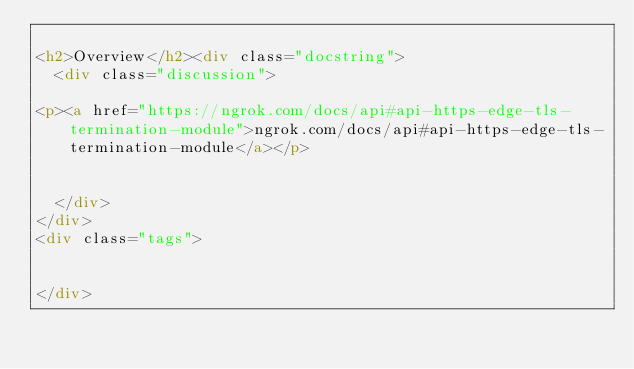<code> <loc_0><loc_0><loc_500><loc_500><_HTML_>
<h2>Overview</h2><div class="docstring">
  <div class="discussion">
    
<p><a href="https://ngrok.com/docs/api#api-https-edge-tls-termination-module">ngrok.com/docs/api#api-https-edge-tls-termination-module</a></p>


  </div>
</div>
<div class="tags">
  

</div></code> 